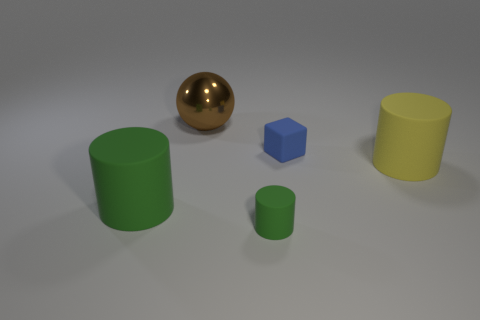Add 2 blue matte things. How many objects exist? 7 Subtract all cylinders. How many objects are left? 2 Add 3 big brown shiny things. How many big brown shiny things are left? 4 Add 2 large red blocks. How many large red blocks exist? 2 Subtract 0 cyan cubes. How many objects are left? 5 Subtract all tiny blue rubber objects. Subtract all balls. How many objects are left? 3 